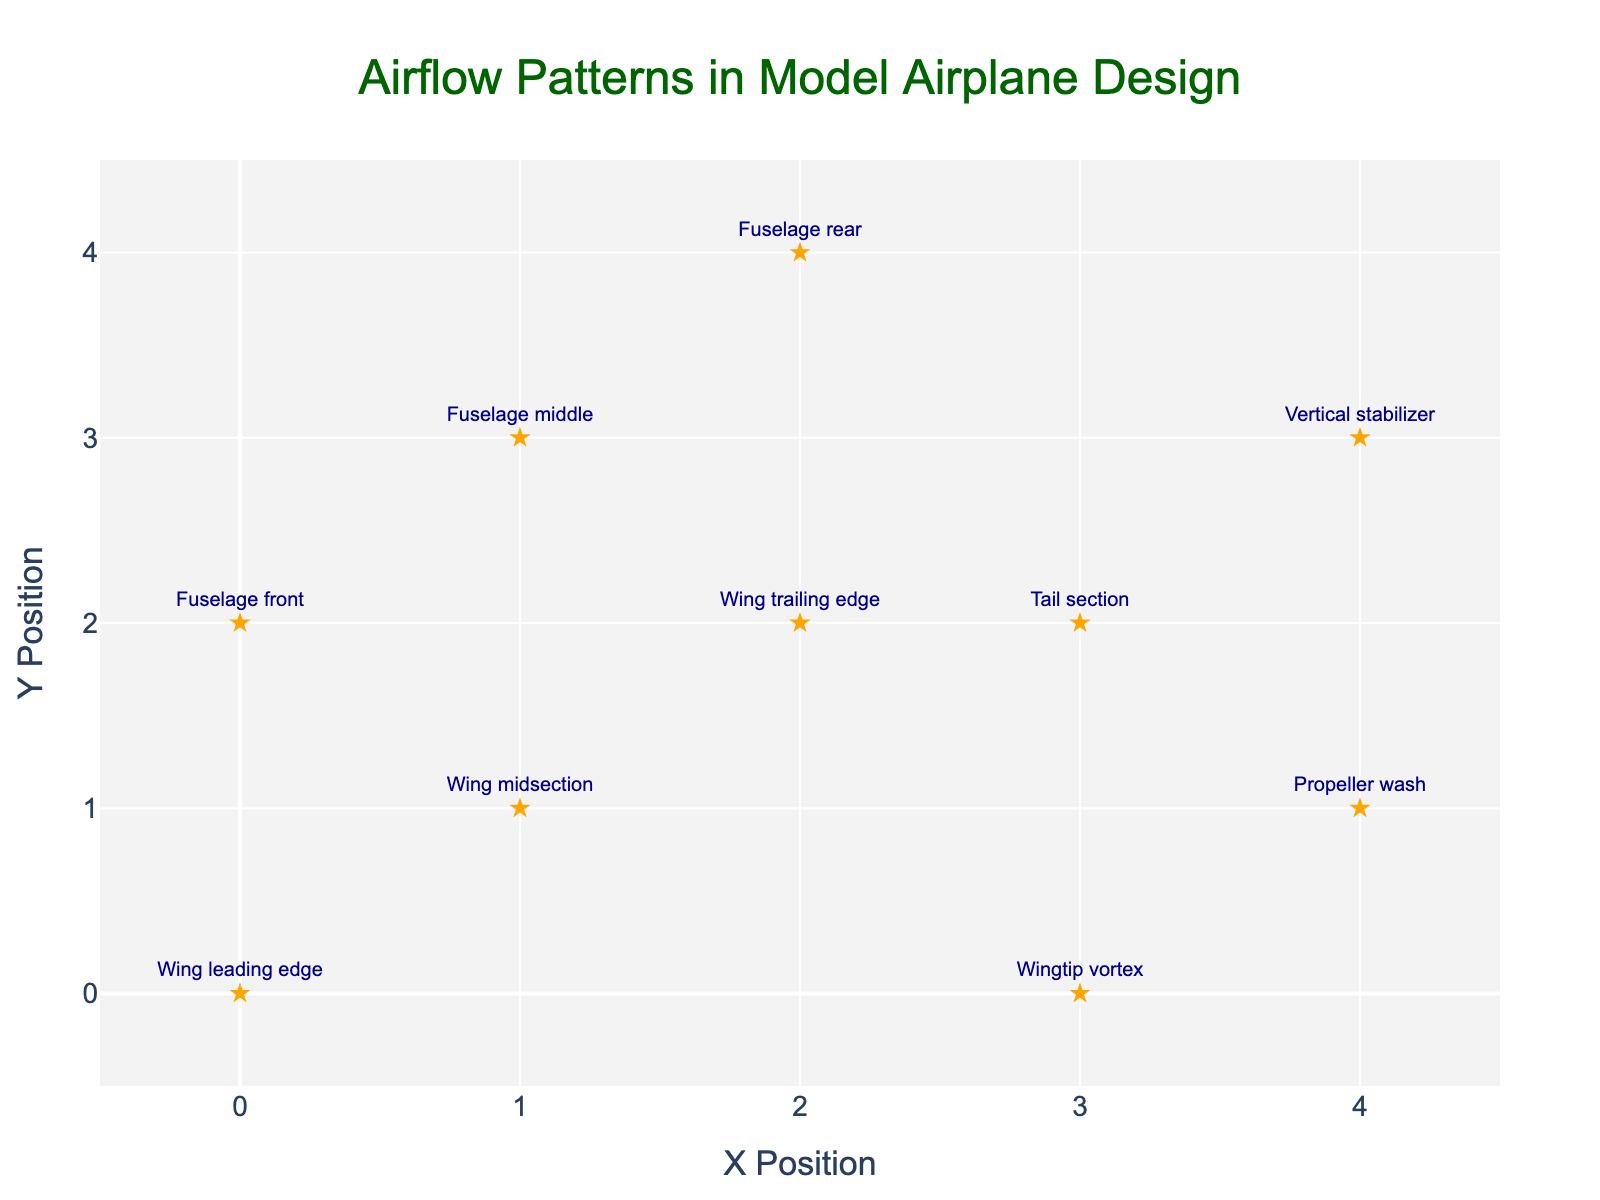What is the title of the figure? The title is typically located at the top and center of the figure. Here, it reads: "Airflow Patterns in Model Airplane Design".
Answer: Airflow Patterns in Model Airplane Design How many data points are shown in the figure? Each data point corresponds to an arrow and a marker in the figure. There are ten data points listed in the dataset, so there should be ten points highlighted in the figure.
Answer: 10 Which component has the highest magnitude? To find the component with the highest magnitude, we compare the 'magnitude' values. The Fuselage rear has the highest magnitude of 5.0.
Answer: Fuselage rear Which component has the lowest magnitude? To determine the lowest magnitude, we look for the smallest 'magnitude' value. The Propeller wash has the lowest magnitude of 0.9.
Answer: Propeller wash What is the direction of the airflow at the Wingtip vortex? The direction is given by the vector components u and v. For Wingtip vortex (x=3, y=0), the airflow direction is (0.8, 1.2).
Answer: (0.8, 1.2) Which section of the airplane has higher airflow magnitudes, wings or fuselage? Summing up magnitudes for the wings (3.1, 3.8, 4.5, 1.4) and fuselage (3.5, 4.4, 5.0) tells us wings have a total of 12.8 and fuselage has 12.9. Since 12.9 > 12.8, the fuselage has higher airflow magnitudes.
Answer: Fuselage What is the average magnitude of airflow across all components? Add all magnitudes (3.1, 3.8, 4.5, 3.5, 4.4, 5.0, 1.4, 2.2, 0.9, 3.1) which equals 31.9, then divide by 10 data points: 31.9/10 = 3.19.
Answer: 3.19 Which component exhibits the most vertical airflow (highest v value)? The vertical component of airflow is given by 'v'. The Fuselage rear has the highest v value of 4.2.
Answer: Fuselage rear In which direction does the airflow at the Vertical stabilizer point? The direction is indicated by the vectors (u,v). For the Vertical stabilizer (x=4, y=3), the airflow points in the direction (1.8, 2.5).
Answer: (1.8, 2.5) Comparing the Wing leading edge and Wing trailing edge, which has a greater horizontal airflow component? The horizontal component 'u' is compared for Wing leading edge (u=2.5) and Wing trailing edge (u=3.8). The Wing trailing edge has a greater horizontal airflow.
Answer: Wing trailing edge 